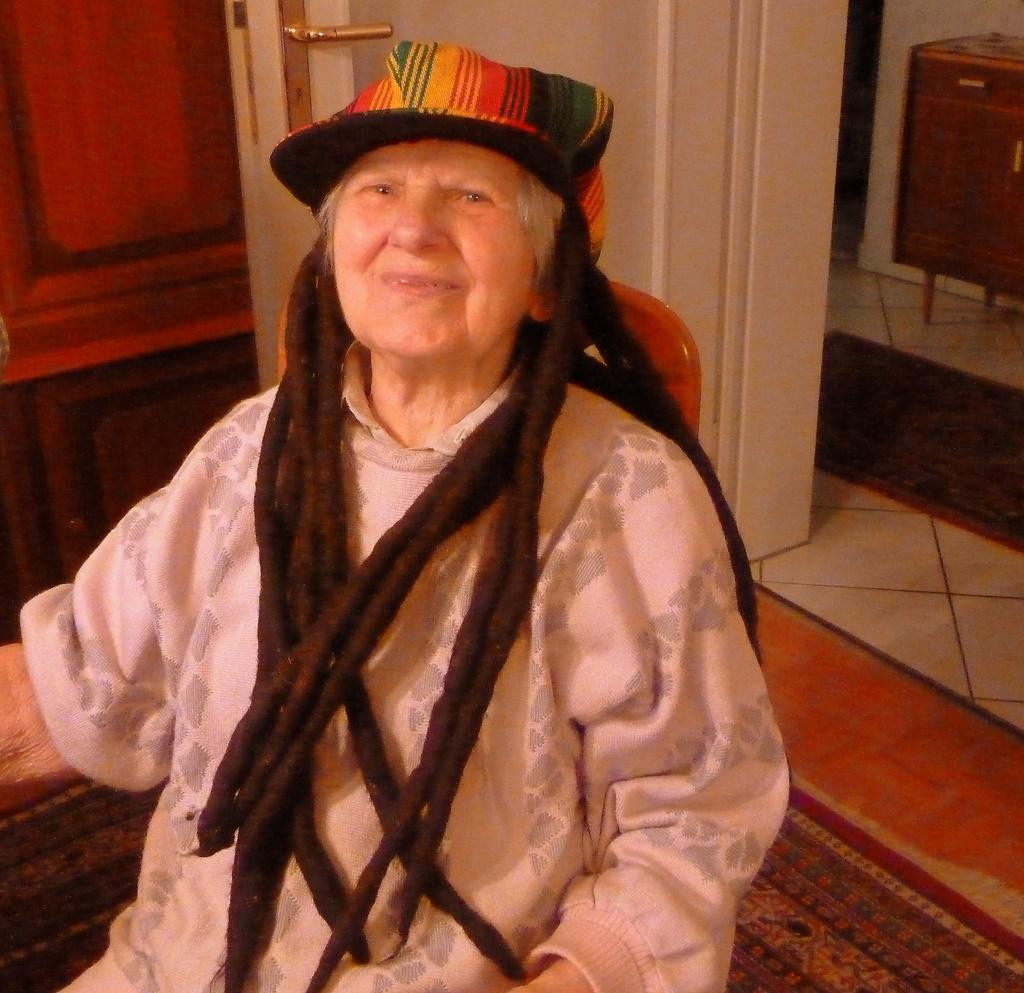What is the main subject of the image? There is an old person sitting on a chair in the image. What can be seen in the background of the image? There is a wall and a door in the background of the image. Are there any other objects visible in the background? Yes, there are other unspecified objects in the background of the image. What type of advice is the old person giving in the image? There is no indication in the image that the old person is giving advice, so it cannot be determined from the picture. 